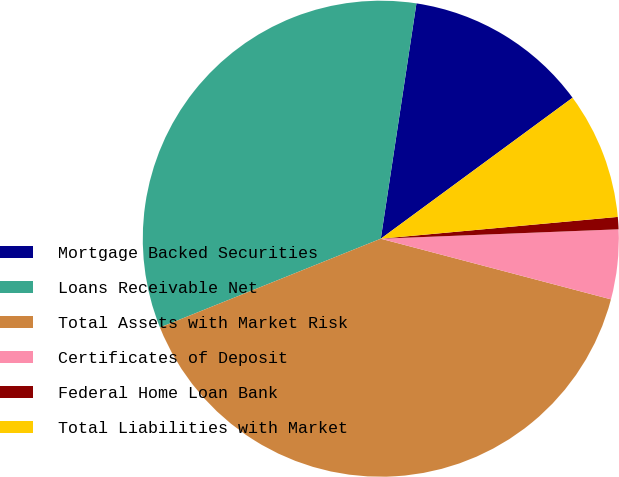Convert chart to OTSL. <chart><loc_0><loc_0><loc_500><loc_500><pie_chart><fcel>Mortgage Backed Securities<fcel>Loans Receivable Net<fcel>Total Assets with Market Risk<fcel>Certificates of Deposit<fcel>Federal Home Loan Bank<fcel>Total Liabilities with Market<nl><fcel>12.52%<fcel>33.48%<fcel>39.82%<fcel>4.73%<fcel>0.83%<fcel>8.63%<nl></chart> 